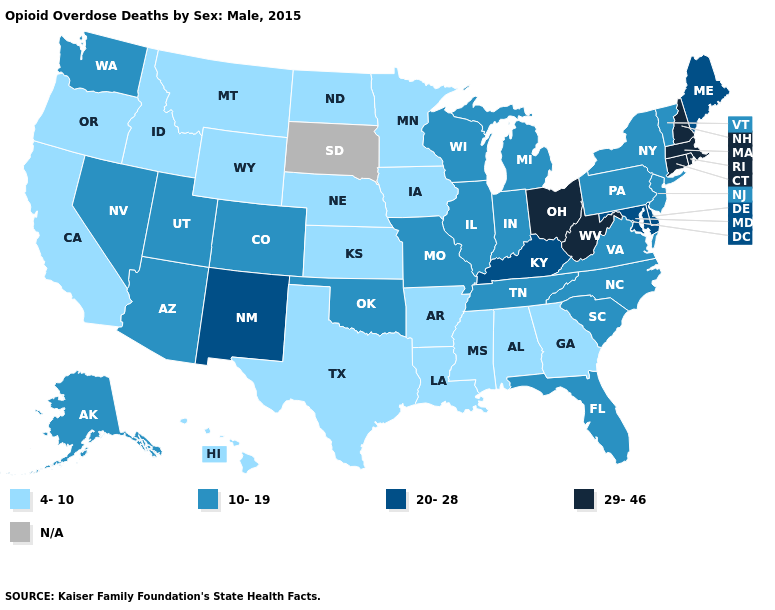How many symbols are there in the legend?
Concise answer only. 5. What is the value of New Hampshire?
Concise answer only. 29-46. Among the states that border New Hampshire , which have the lowest value?
Answer briefly. Vermont. What is the highest value in the West ?
Short answer required. 20-28. Name the states that have a value in the range 4-10?
Concise answer only. Alabama, Arkansas, California, Georgia, Hawaii, Idaho, Iowa, Kansas, Louisiana, Minnesota, Mississippi, Montana, Nebraska, North Dakota, Oregon, Texas, Wyoming. What is the value of Utah?
Keep it brief. 10-19. What is the highest value in the West ?
Answer briefly. 20-28. What is the lowest value in the Northeast?
Be succinct. 10-19. Among the states that border Illinois , which have the lowest value?
Answer briefly. Iowa. What is the value of Georgia?
Write a very short answer. 4-10. Among the states that border Arkansas , does Louisiana have the highest value?
Keep it brief. No. Which states hav the highest value in the West?
Give a very brief answer. New Mexico. Does the map have missing data?
Be succinct. Yes. 